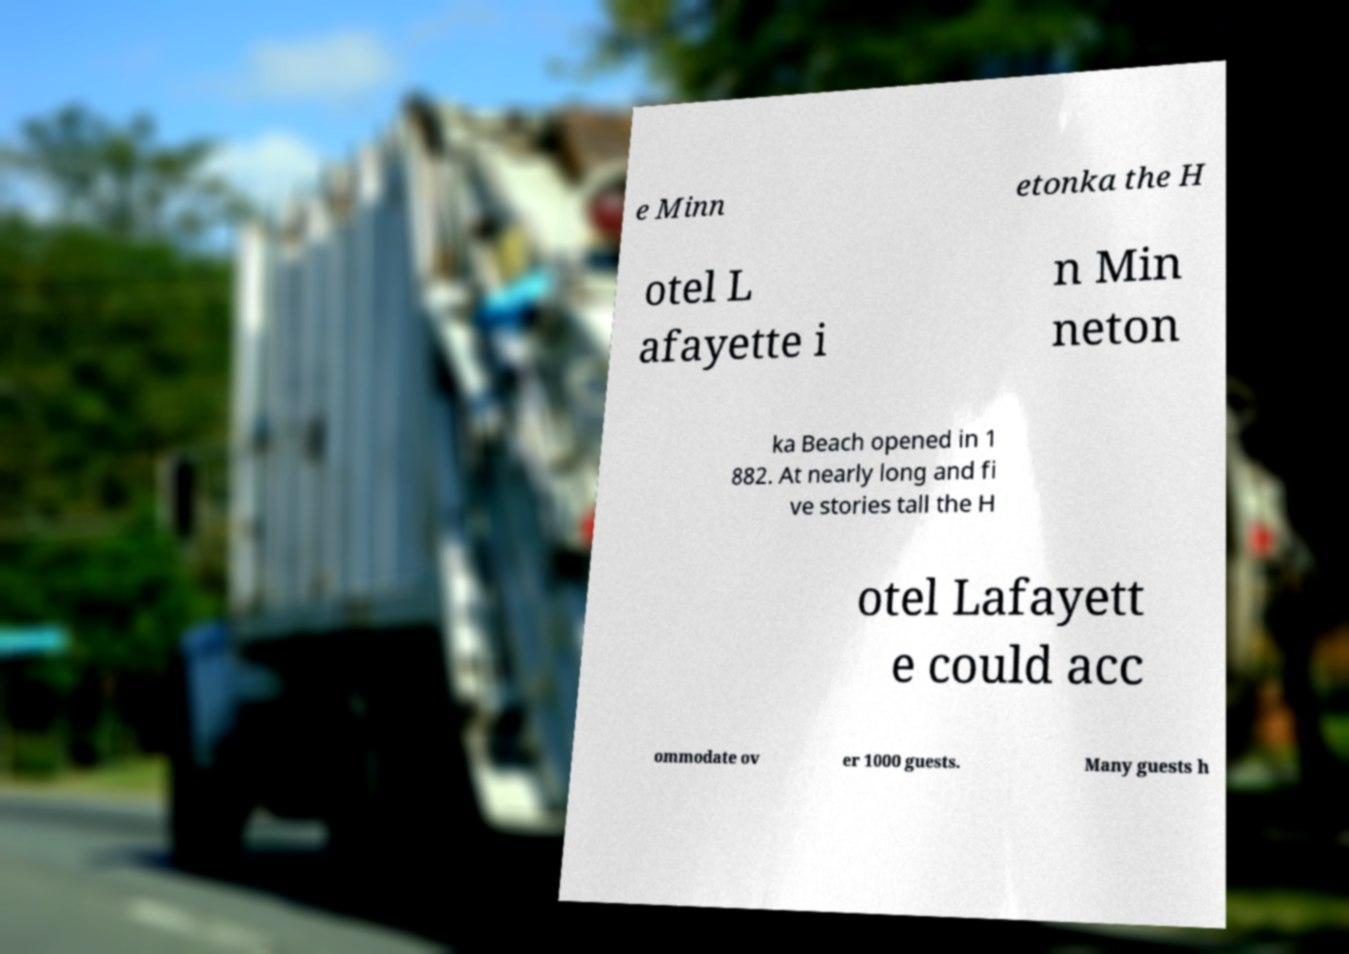Can you read and provide the text displayed in the image?This photo seems to have some interesting text. Can you extract and type it out for me? e Minn etonka the H otel L afayette i n Min neton ka Beach opened in 1 882. At nearly long and fi ve stories tall the H otel Lafayett e could acc ommodate ov er 1000 guests. Many guests h 